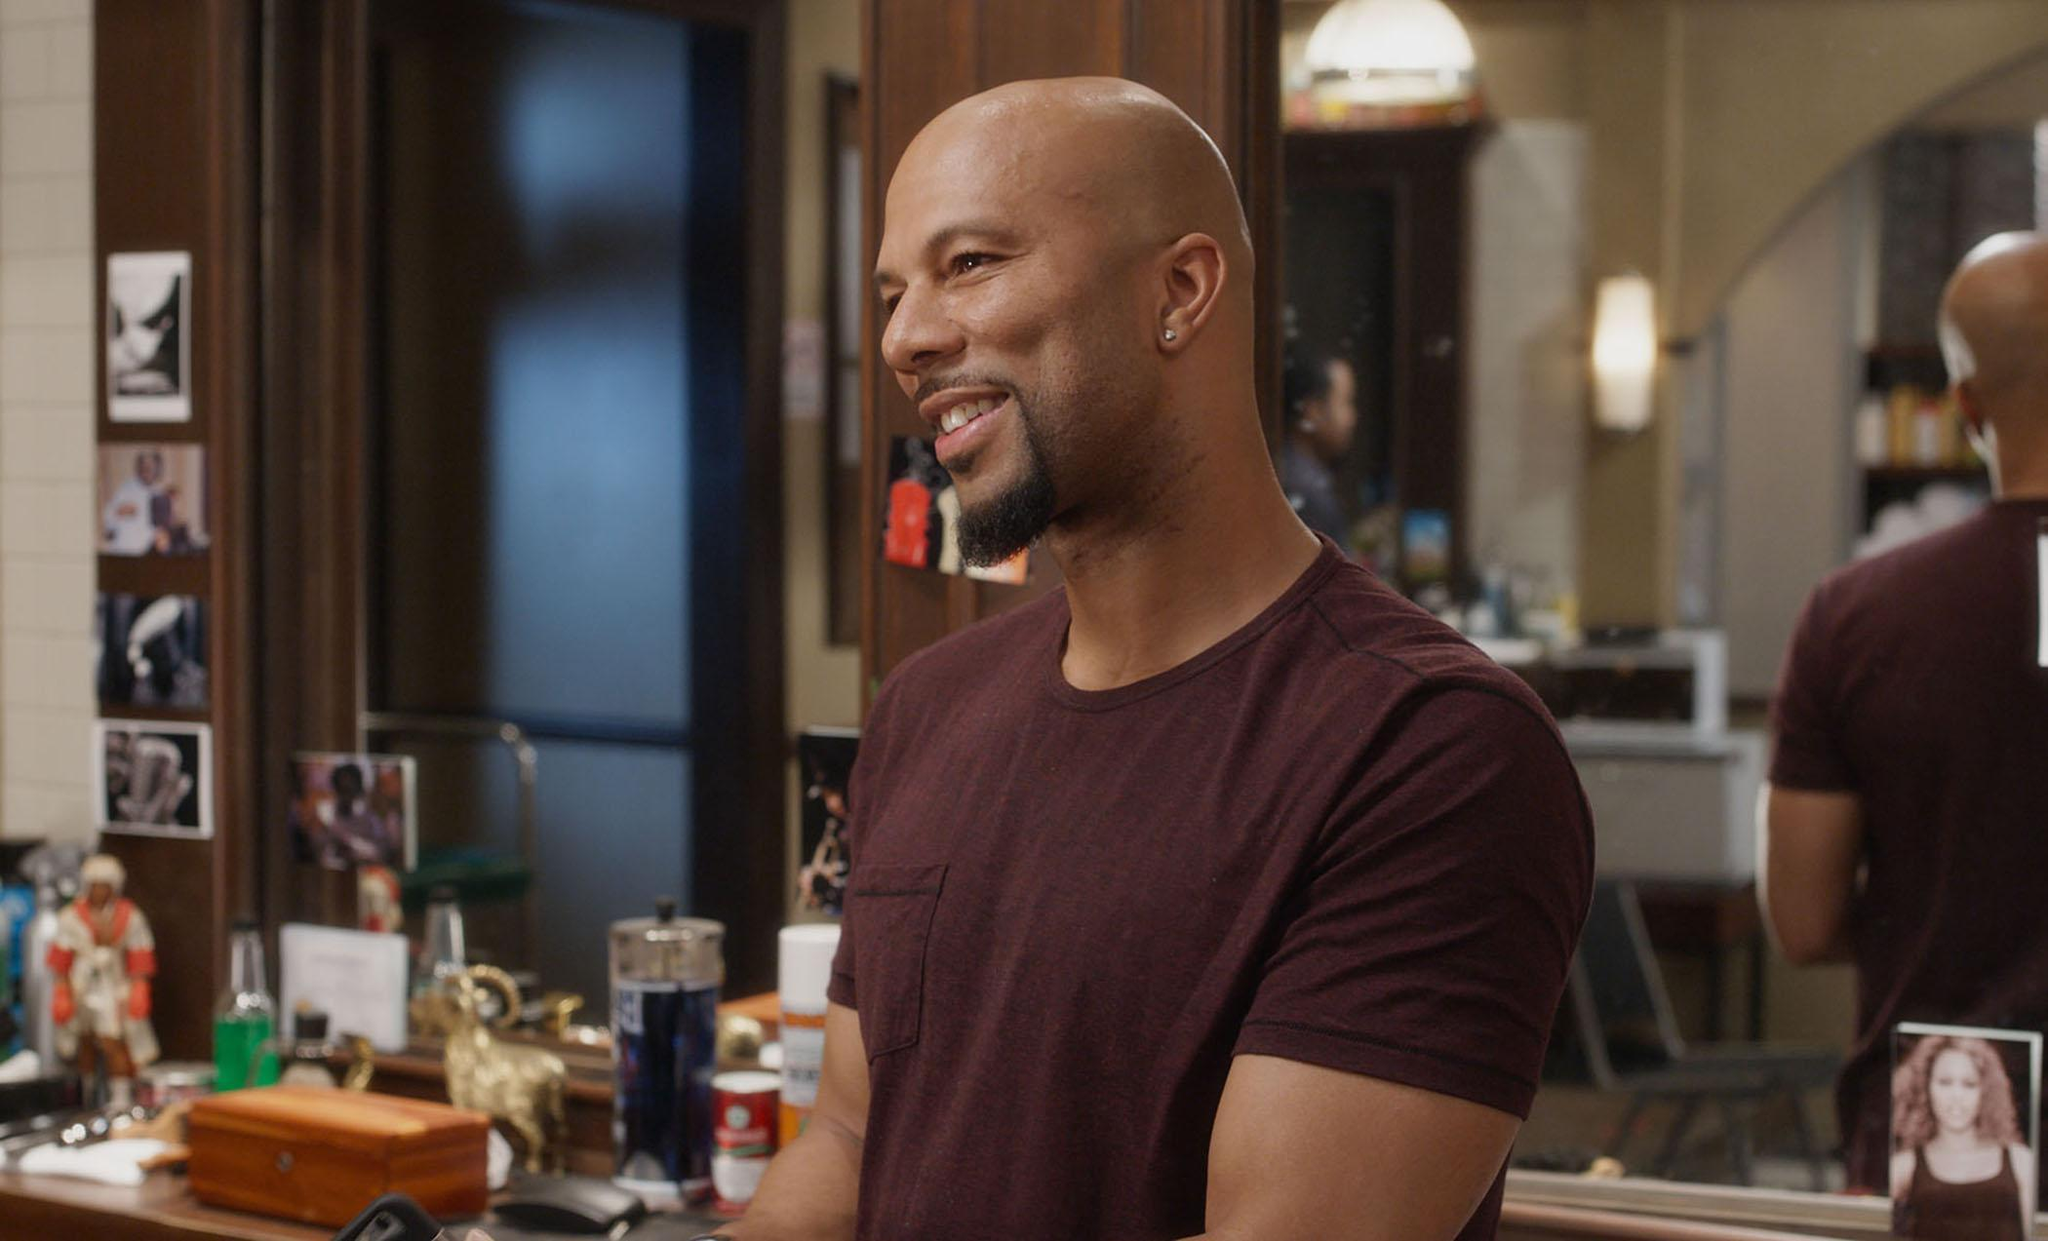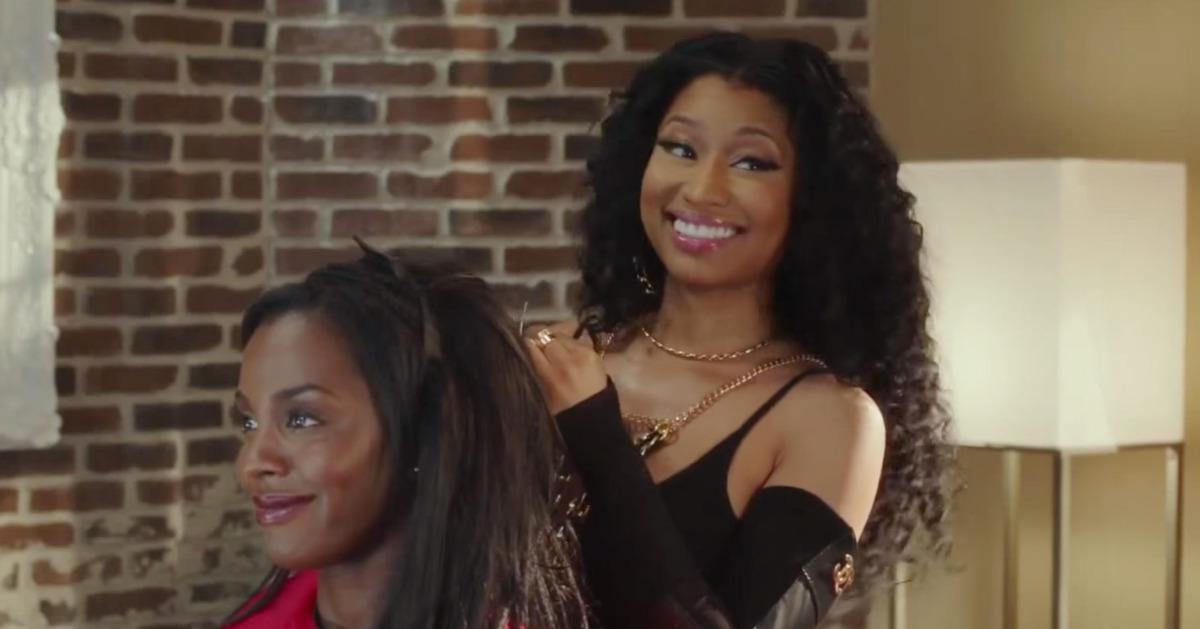The first image is the image on the left, the second image is the image on the right. Given the left and right images, does the statement "The woman in the image on the right is standing in front of a brick wall." hold true? Answer yes or no. Yes. The first image is the image on the left, the second image is the image on the right. For the images displayed, is the sentence "An image includes a black man with grizzled gray hair and beard, wearing a white top and khaki pants, and sitting in a barber chair." factually correct? Answer yes or no. No. 